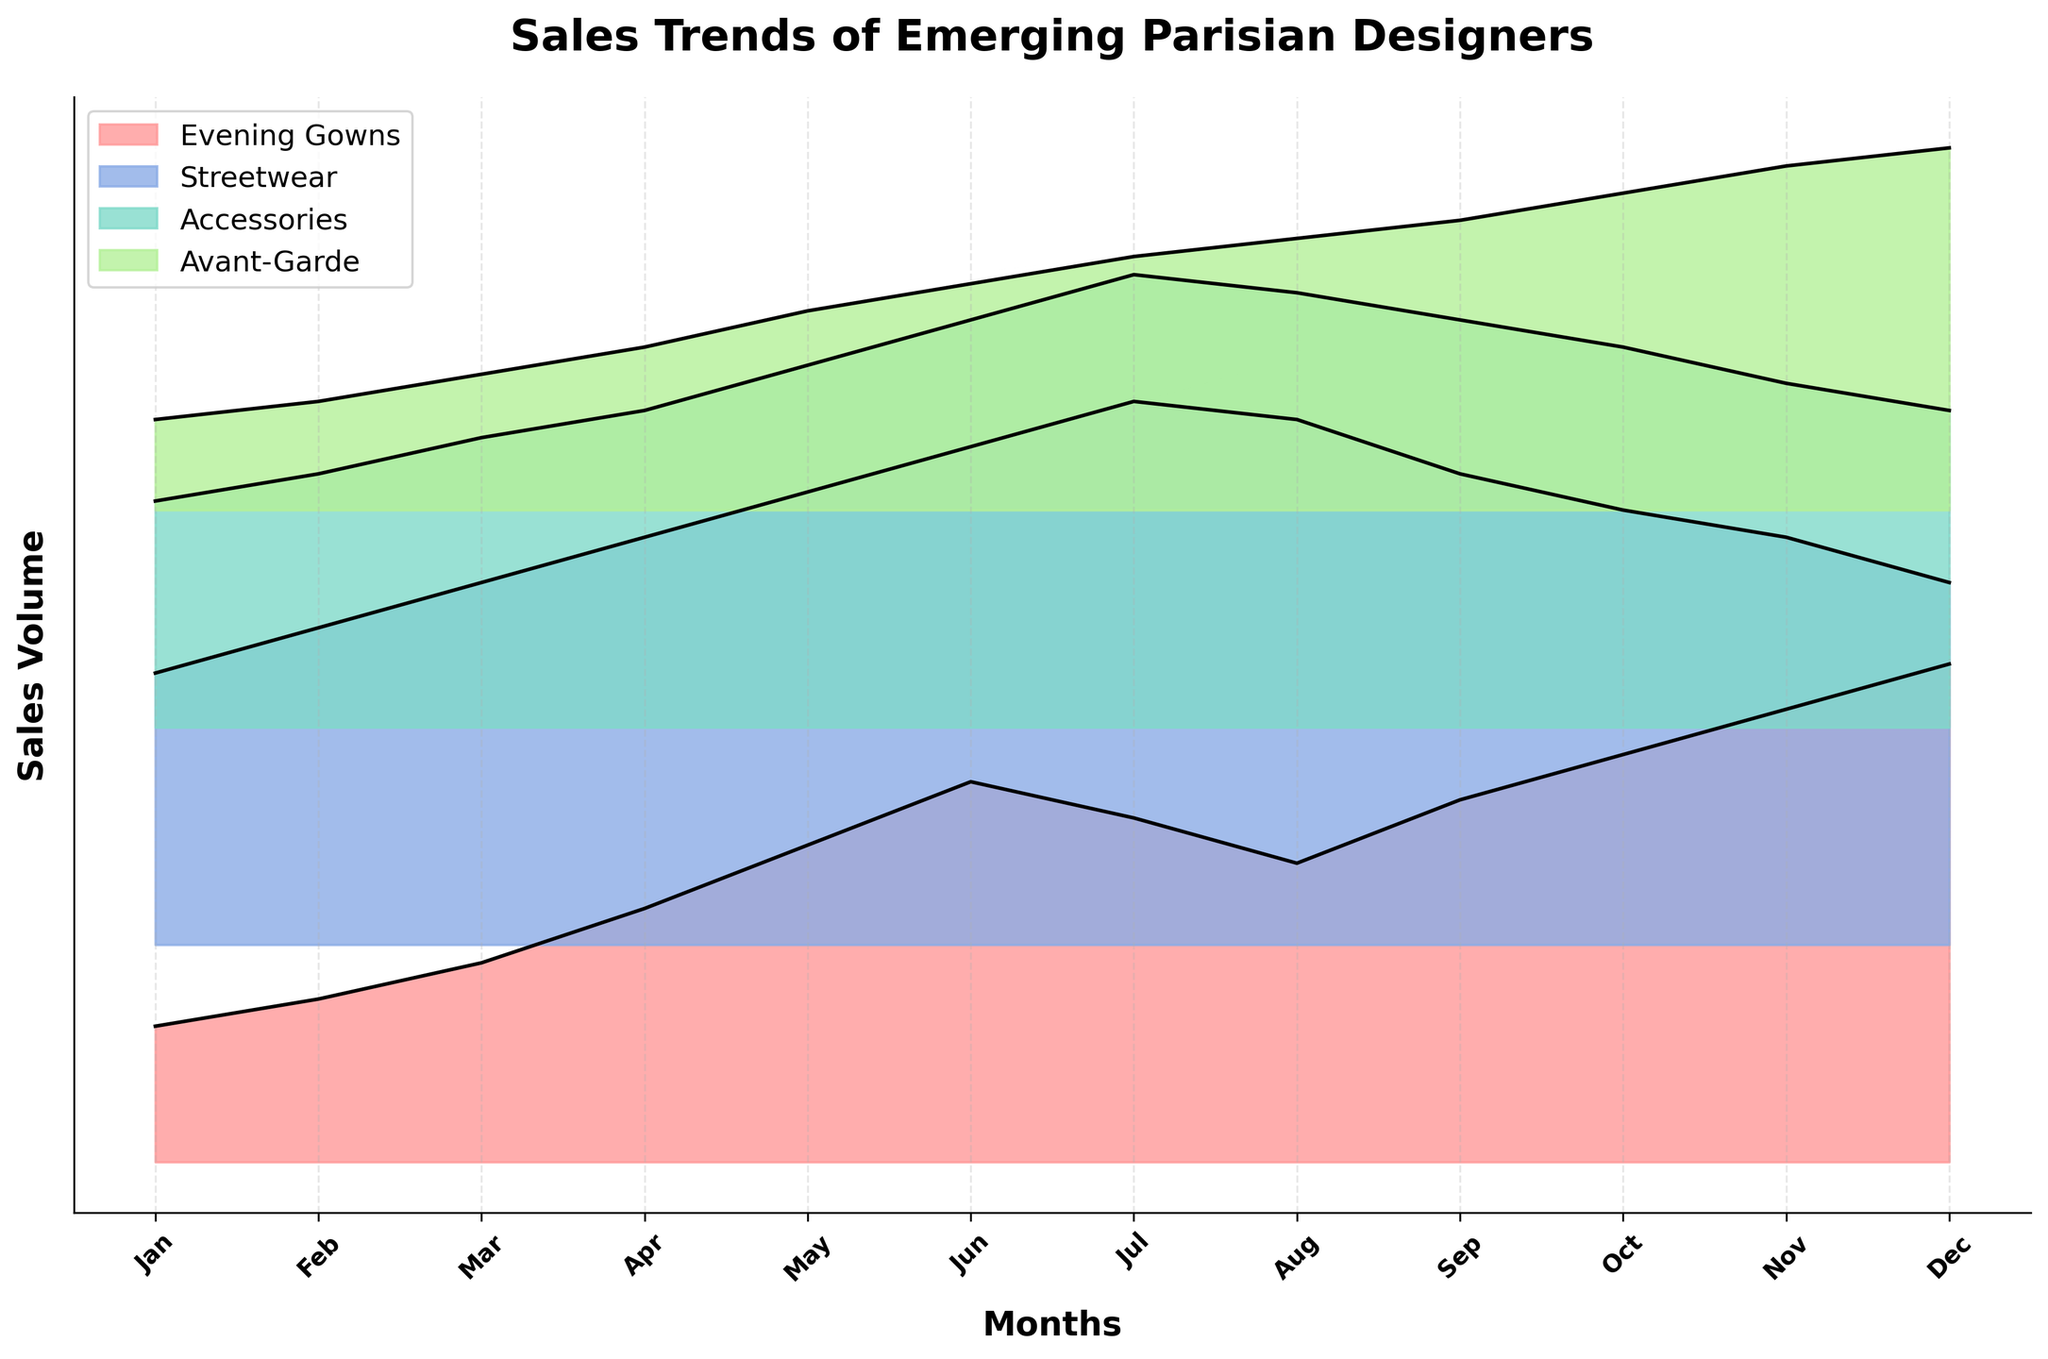Which category has the highest sales in December? Look for the line representing December at the far right and compare the peaks for each category.
Answer: Evening Gowns Which month shows the peak sales for Streetwear? Trace the line representing Streetwear and identify the month where it reaches its highest point.
Answer: July What's the difference in sales volume between Evening Gowns in January and December? Check the offset level for Evening Gowns in January and December and subtract the lower from the higher value.
Answer: 40 Which category experienced a steady increase in sales over the year? Observe the trendlines of each category and identify which one consistently rises without significant dips.
Answer: Avant-Garde In which month did Accessories reach their peak sales? Follow the Accessories trendline to spot the month where it hits its highest peak.
Answer: July Compare the sales volume of Evening Gowns and Streetwear in May. Which category has higher sales? Compare the offsets for both categories in May and see which has a higher peak.
Answer: Streetwear What is the overall trend for Accessories throughout the year? Observe the entire trendline for Accessories and summarize the general direction and fluctuations.
Answer: Increasing then decreasing How does the sales trend of Avant-Garde compare to that of Streetwear during the summer months (June, July, August)? Assess the trendlines for both categories over the specified months and note any differences or similarities in their sales patterns.
Answer: Avant-Garde increases steadily, while Streetwear peaks and then decreases Which category shows a decline in sales as the year progresses after a mid-year peak? Inspect the trendlines for each category and identify which one decreases after reaching a high point mid-year.
Answer: Streetwear 